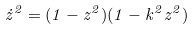Convert formula to latex. <formula><loc_0><loc_0><loc_500><loc_500>\dot { z } ^ { 2 } = ( 1 - z ^ { 2 } ) ( 1 - k ^ { 2 } z ^ { 2 } )</formula> 